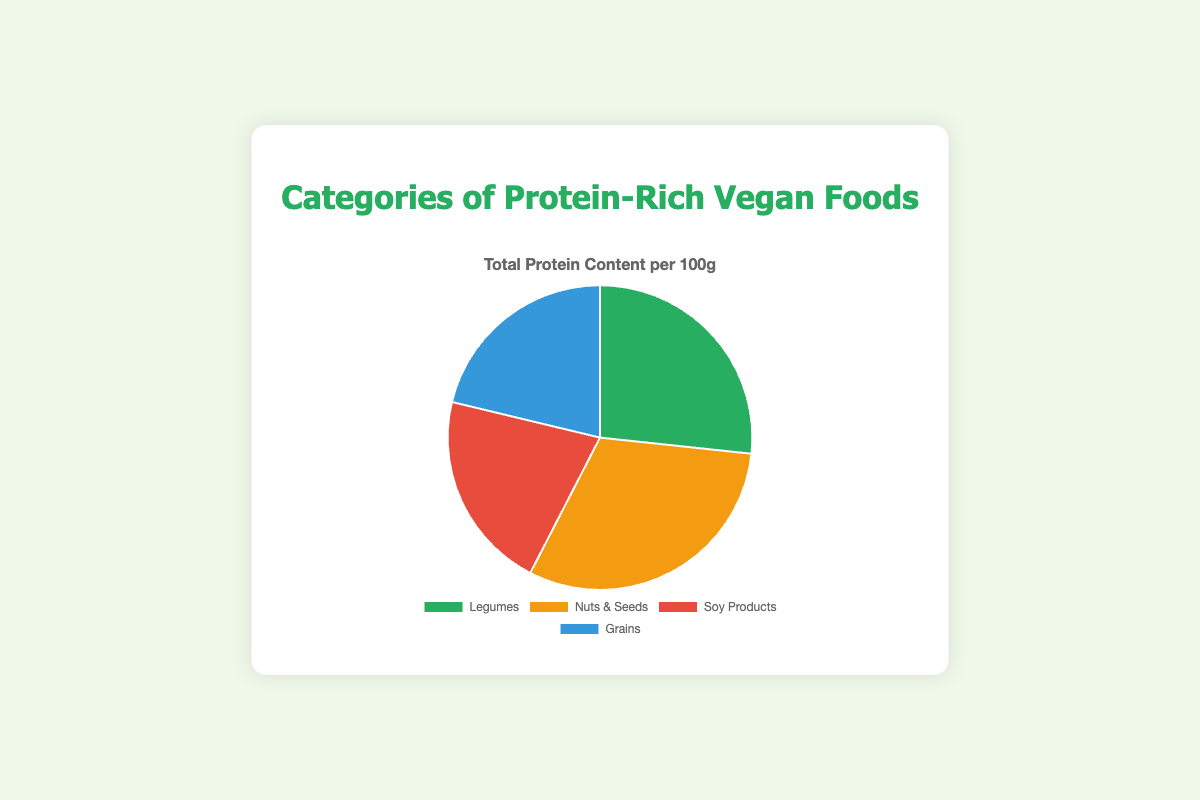Which category has the highest protein content per 100g? The pie chart shows four categories with distinct percentages representing their total protein content per 100g. The category with the largest slice is "Nuts & Seeds".
Answer: Nuts & Seeds What is the total protein content for 'Grains' and 'Soy Products' combined? According to the pie chart, 'Grains' has 39g of protein content per 100g, and 'Soy Products' has 38.9g. Adding these values together: 39 + 38.9 = 77.9.
Answer: 77.9 Which category has a protein content almost equal to 50g? Observing the pie chart, 'Legumes' has a protein content of 49g per 100g, which is closest to 50g.
Answer: Legumes How do the protein contents of 'Legumes' and 'Nuts & Seeds' compare? 'Nuts & Seeds' has a higher protein content at 56.7g compared to 'Legumes' at 49g. Therefore, 'Nuts & Seeds' has more protein than 'Legumes'.
Answer: Nuts & Seeds has more protein Which two categories combined have the lowest total protein content? The protein contents are: Legumes (49g), Nuts & Seeds (56.7g), Soy Products (38.9g), and Grains (39g). Summing the smallest values: Soy Products and Grains, 38.9 + 39 = 77.9, which is the lowest combined total.
Answer: Soy Products and Grains What percentage of the total protein content does 'Soy Products' represent? The sum of all categories' protein contents is 49 + 56.7 + 38.9 + 39 = 183.6. The percentage for 'Soy Products' is (38.9 / 183.6) * 100%, which is approximately 21.1%.
Answer: ~21.1% Which category is represented in blue on the pie chart? The blue segment of the pie chart corresponds to 'Grains'.
Answer: Grains If you combine 'Legumes' and 'Grains', what is their share relative to the total protein content? 'Legumes' protein content is 49g and 'Grains' is 39g. Combined, they equal 49 + 39 = 88g. The total protein content is 183.6g. Their share is (88 / 183.6) * 100%, which is about 47.92%.
Answer: ~47.92% Which category has the smallest share of the total protein content? The smallest slice in the pie chart corresponds to 'Soy Products' at 38.9g.
Answer: Soy Products 